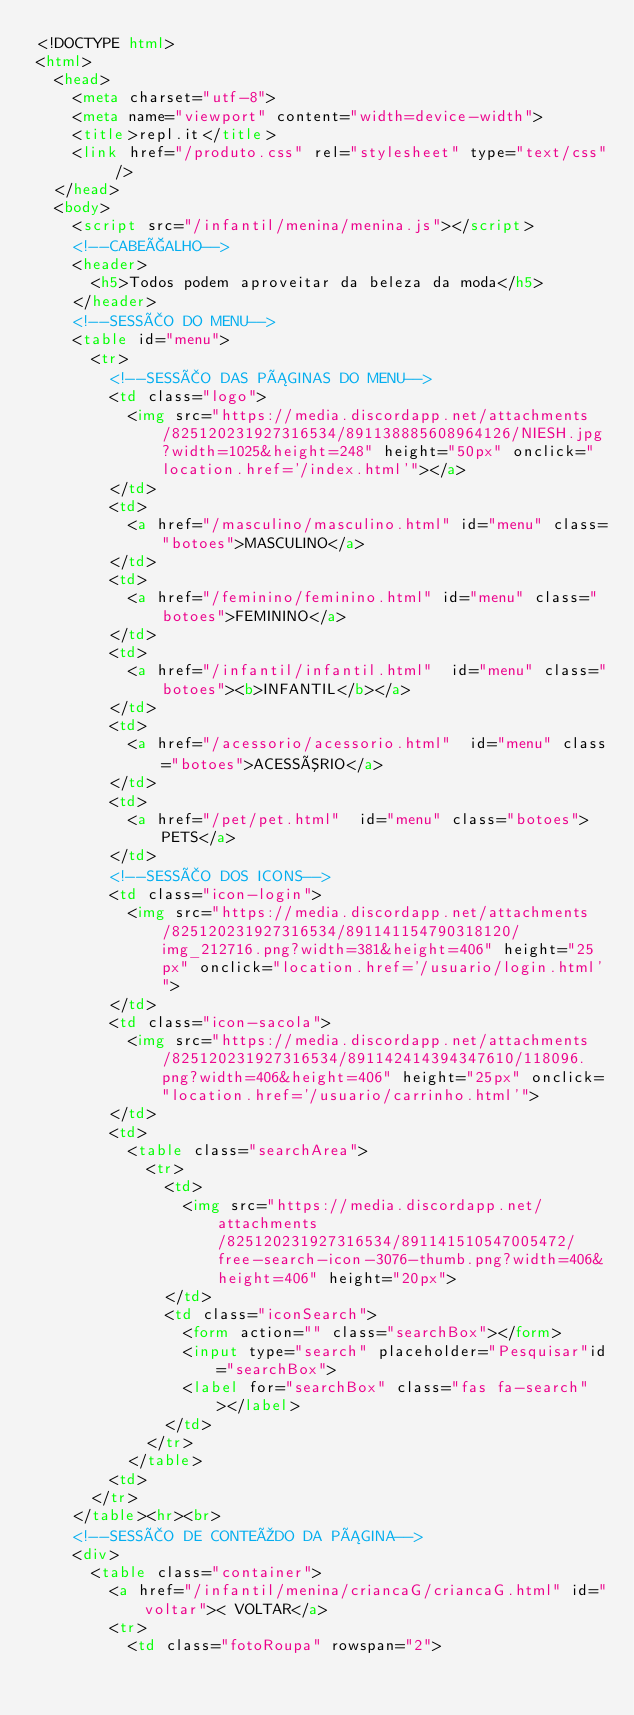Convert code to text. <code><loc_0><loc_0><loc_500><loc_500><_HTML_><!DOCTYPE html>
<html>
  <head>
    <meta charset="utf-8">
    <meta name="viewport" content="width=device-width">
    <title>repl.it</title>
    <link href="/produto.css" rel="stylesheet" type="text/css" />
  </head>
  <body>
    <script src="/infantil/menina/menina.js"></script>
    <!--CABEÇALHO-->
    <header>
      <h5>Todos podem aproveitar da beleza da moda</h5>
    </header>
    <!--SESSÃO DO MENU-->
    <table id="menu">
      <tr>
        <!--SESSÃO DAS PÁGINAS DO MENU-->
        <td class="logo">
          <img src="https://media.discordapp.net/attachments/825120231927316534/891138885608964126/NIESH.jpg?width=1025&height=248" height="50px" onclick="location.href='/index.html'"></a>
        </td>
        <td>
          <a href="/masculino/masculino.html" id="menu" class="botoes">MASCULINO</a>
        </td>
        <td>
          <a href="/feminino/feminino.html" id="menu" class="botoes">FEMININO</a>
        </td>
        <td>
          <a href="/infantil/infantil.html"  id="menu" class="botoes"><b>INFANTIL</b></a>
        </td>
        <td>
          <a href="/acessorio/acessorio.html"  id="menu" class="botoes">ACESSÓRIO</a>
        </td>
        <td>
          <a href="/pet/pet.html"  id="menu" class="botoes">PETS</a>
        </td>
        <!--SESSÃO DOS ICONS-->
        <td class="icon-login">
          <img src="https://media.discordapp.net/attachments/825120231927316534/891141154790318120/img_212716.png?width=381&height=406" height="25px" onclick="location.href='/usuario/login.html'">
        </td>
        <td class="icon-sacola">
          <img src="https://media.discordapp.net/attachments/825120231927316534/891142414394347610/118096.png?width=406&height=406" height="25px" onclick="location.href='/usuario/carrinho.html'">
        </td>
        <td>  
          <table class="searchArea">
            <tr>
              <td>
                <img src="https://media.discordapp.net/attachments/825120231927316534/891141510547005472/free-search-icon-3076-thumb.png?width=406&height=406" height="20px">
              </td>
              <td class="iconSearch">
                <form action="" class="searchBox"></form>
                <input type="search" placeholder="Pesquisar"id="searchBox">
                <label for="searchBox" class="fas fa-search"></label> 
              </td>
            </tr>
          </table>
        <td>
      </tr>
    </table><hr><br>
    <!--SESSÃO DE CONTEÚDO DA PÁGINA-->
    <div>
      <table class="container">
        <a href="/infantil/menina/criancaG/criancaG.html" id="voltar">< VOLTAR</a>
        <tr>
          <td class="fotoRoupa" rowspan="2"></code> 